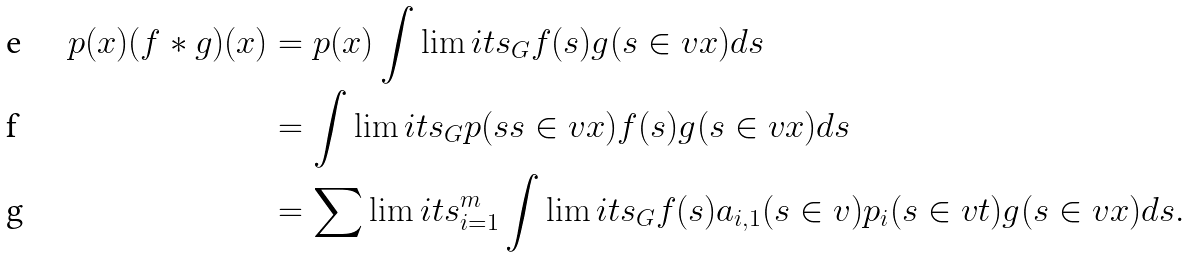Convert formula to latex. <formula><loc_0><loc_0><loc_500><loc_500>p ( x ) ( f \ast g ) ( x ) & = p ( x ) \int \lim i t s _ { G } f ( s ) g ( s \in v x ) d s \\ & = \int \lim i t s _ { G } p ( s s \in v x ) f ( s ) g ( s \in v x ) d s \\ & = \sum \lim i t s _ { i = 1 } ^ { m } \int \lim i t s _ { G } f ( s ) a _ { i , 1 } ( s \in v ) p _ { i } ( s \in v t ) g ( s \in v x ) d s .</formula> 